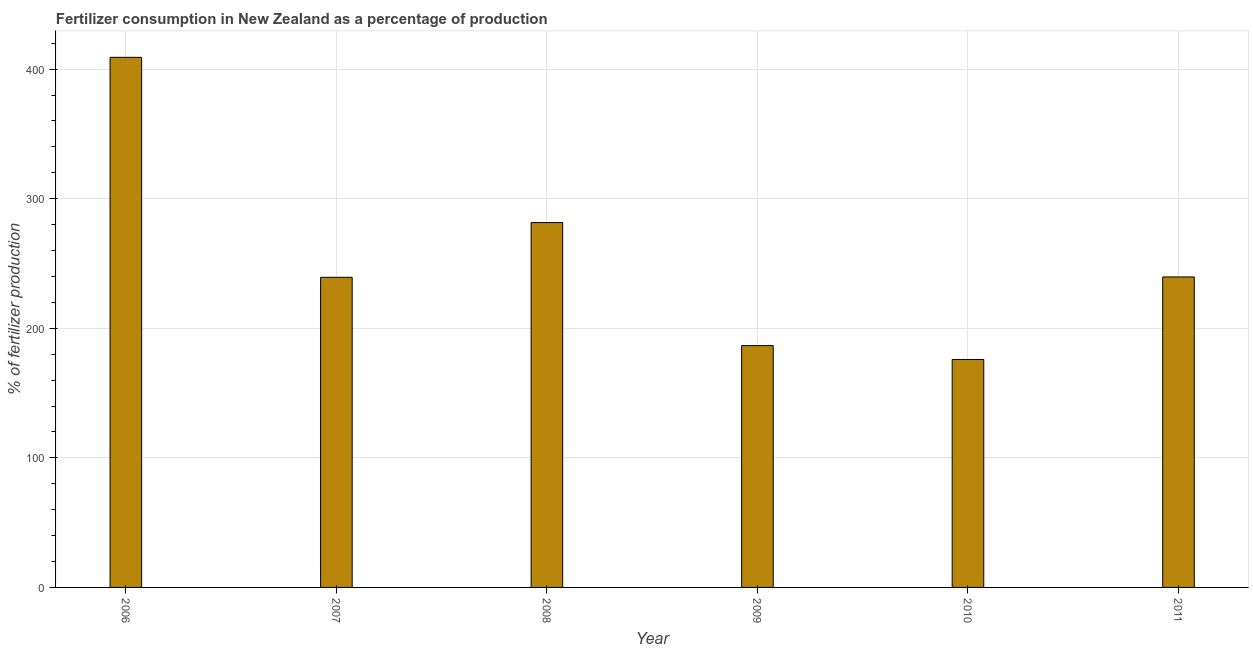Does the graph contain any zero values?
Ensure brevity in your answer.  No. What is the title of the graph?
Provide a succinct answer. Fertilizer consumption in New Zealand as a percentage of production. What is the label or title of the Y-axis?
Offer a very short reply. % of fertilizer production. What is the amount of fertilizer consumption in 2006?
Provide a short and direct response. 409.12. Across all years, what is the maximum amount of fertilizer consumption?
Provide a short and direct response. 409.12. Across all years, what is the minimum amount of fertilizer consumption?
Offer a very short reply. 175.93. What is the sum of the amount of fertilizer consumption?
Your response must be concise. 1532.22. What is the difference between the amount of fertilizer consumption in 2009 and 2010?
Your response must be concise. 10.7. What is the average amount of fertilizer consumption per year?
Provide a succinct answer. 255.37. What is the median amount of fertilizer consumption?
Your response must be concise. 239.48. In how many years, is the amount of fertilizer consumption greater than 240 %?
Your response must be concise. 2. Do a majority of the years between 2008 and 2010 (inclusive) have amount of fertilizer consumption greater than 340 %?
Keep it short and to the point. No. What is the ratio of the amount of fertilizer consumption in 2007 to that in 2009?
Keep it short and to the point. 1.28. What is the difference between the highest and the second highest amount of fertilizer consumption?
Keep it short and to the point. 127.54. Is the sum of the amount of fertilizer consumption in 2007 and 2009 greater than the maximum amount of fertilizer consumption across all years?
Your response must be concise. Yes. What is the difference between the highest and the lowest amount of fertilizer consumption?
Offer a very short reply. 233.19. How many bars are there?
Give a very brief answer. 6. How many years are there in the graph?
Offer a terse response. 6. What is the difference between two consecutive major ticks on the Y-axis?
Offer a terse response. 100. Are the values on the major ticks of Y-axis written in scientific E-notation?
Offer a very short reply. No. What is the % of fertilizer production in 2006?
Make the answer very short. 409.12. What is the % of fertilizer production of 2007?
Offer a very short reply. 239.35. What is the % of fertilizer production in 2008?
Your response must be concise. 281.58. What is the % of fertilizer production in 2009?
Your response must be concise. 186.63. What is the % of fertilizer production in 2010?
Keep it short and to the point. 175.93. What is the % of fertilizer production in 2011?
Give a very brief answer. 239.62. What is the difference between the % of fertilizer production in 2006 and 2007?
Provide a short and direct response. 169.77. What is the difference between the % of fertilizer production in 2006 and 2008?
Provide a short and direct response. 127.54. What is the difference between the % of fertilizer production in 2006 and 2009?
Your answer should be very brief. 222.49. What is the difference between the % of fertilizer production in 2006 and 2010?
Your answer should be very brief. 233.19. What is the difference between the % of fertilizer production in 2006 and 2011?
Your response must be concise. 169.5. What is the difference between the % of fertilizer production in 2007 and 2008?
Your answer should be compact. -42.23. What is the difference between the % of fertilizer production in 2007 and 2009?
Your response must be concise. 52.72. What is the difference between the % of fertilizer production in 2007 and 2010?
Make the answer very short. 63.42. What is the difference between the % of fertilizer production in 2007 and 2011?
Your response must be concise. -0.27. What is the difference between the % of fertilizer production in 2008 and 2009?
Your answer should be very brief. 94.95. What is the difference between the % of fertilizer production in 2008 and 2010?
Ensure brevity in your answer.  105.65. What is the difference between the % of fertilizer production in 2008 and 2011?
Make the answer very short. 41.96. What is the difference between the % of fertilizer production in 2009 and 2010?
Your response must be concise. 10.7. What is the difference between the % of fertilizer production in 2009 and 2011?
Provide a short and direct response. -52.99. What is the difference between the % of fertilizer production in 2010 and 2011?
Ensure brevity in your answer.  -63.69. What is the ratio of the % of fertilizer production in 2006 to that in 2007?
Offer a terse response. 1.71. What is the ratio of the % of fertilizer production in 2006 to that in 2008?
Ensure brevity in your answer.  1.45. What is the ratio of the % of fertilizer production in 2006 to that in 2009?
Make the answer very short. 2.19. What is the ratio of the % of fertilizer production in 2006 to that in 2010?
Offer a very short reply. 2.33. What is the ratio of the % of fertilizer production in 2006 to that in 2011?
Provide a short and direct response. 1.71. What is the ratio of the % of fertilizer production in 2007 to that in 2008?
Your answer should be very brief. 0.85. What is the ratio of the % of fertilizer production in 2007 to that in 2009?
Ensure brevity in your answer.  1.28. What is the ratio of the % of fertilizer production in 2007 to that in 2010?
Make the answer very short. 1.36. What is the ratio of the % of fertilizer production in 2007 to that in 2011?
Your answer should be very brief. 1. What is the ratio of the % of fertilizer production in 2008 to that in 2009?
Offer a terse response. 1.51. What is the ratio of the % of fertilizer production in 2008 to that in 2010?
Your answer should be compact. 1.6. What is the ratio of the % of fertilizer production in 2008 to that in 2011?
Provide a succinct answer. 1.18. What is the ratio of the % of fertilizer production in 2009 to that in 2010?
Provide a short and direct response. 1.06. What is the ratio of the % of fertilizer production in 2009 to that in 2011?
Offer a very short reply. 0.78. What is the ratio of the % of fertilizer production in 2010 to that in 2011?
Your answer should be compact. 0.73. 